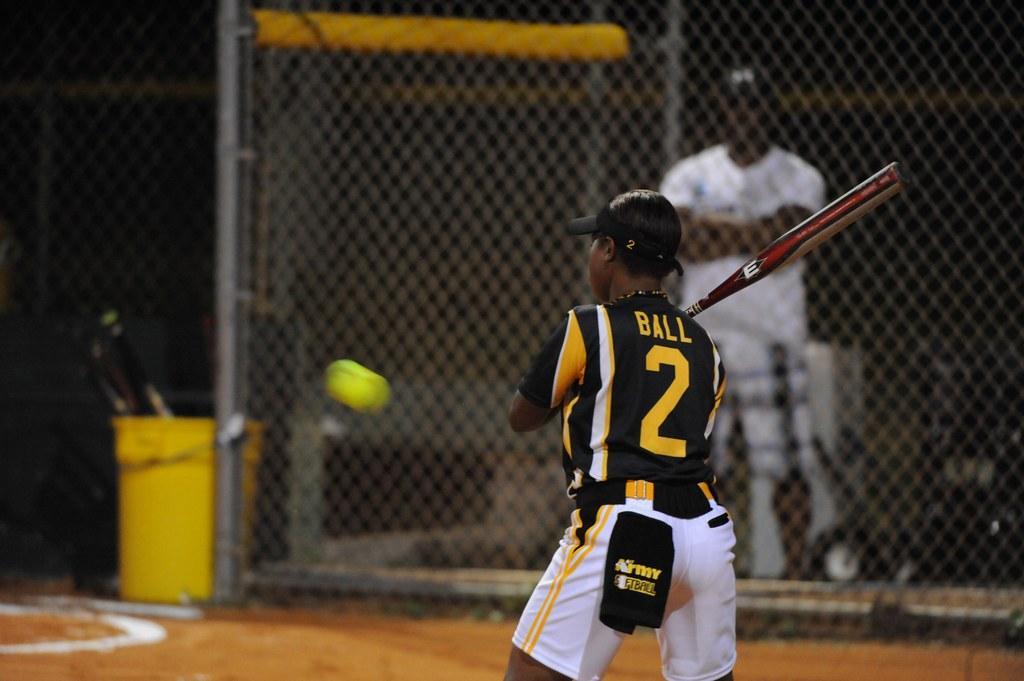<image>
Present a compact description of the photo's key features. A batter named Ball prepares to swing at a baseball. 